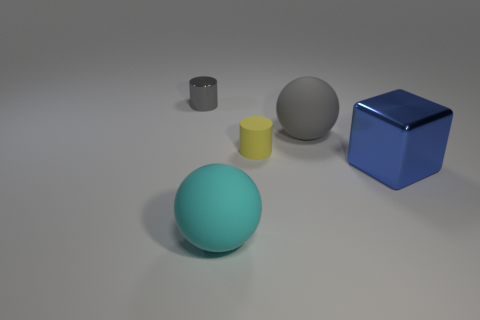There is a ball behind the blue shiny object; is its color the same as the small metal thing?
Make the answer very short. Yes. There is a large ball that is the same color as the metal cylinder; what material is it?
Give a very brief answer. Rubber. Do the gray object that is left of the rubber cylinder and the yellow object have the same size?
Keep it short and to the point. Yes. Is there a big rubber ball of the same color as the small metallic cylinder?
Provide a succinct answer. Yes. Are there any gray objects that are right of the tiny cylinder to the left of the small yellow matte object?
Provide a succinct answer. Yes. Are there any tiny yellow cylinders made of the same material as the tiny gray thing?
Ensure brevity in your answer.  No. What is the material of the cylinder that is on the right side of the small object that is behind the big gray rubber thing?
Provide a succinct answer. Rubber. There is a object that is both behind the tiny yellow rubber cylinder and to the left of the big gray rubber ball; what material is it?
Make the answer very short. Metal. Are there the same number of tiny cylinders that are behind the yellow matte cylinder and small shiny objects?
Provide a short and direct response. Yes. How many small yellow things are the same shape as the tiny gray object?
Keep it short and to the point. 1. 